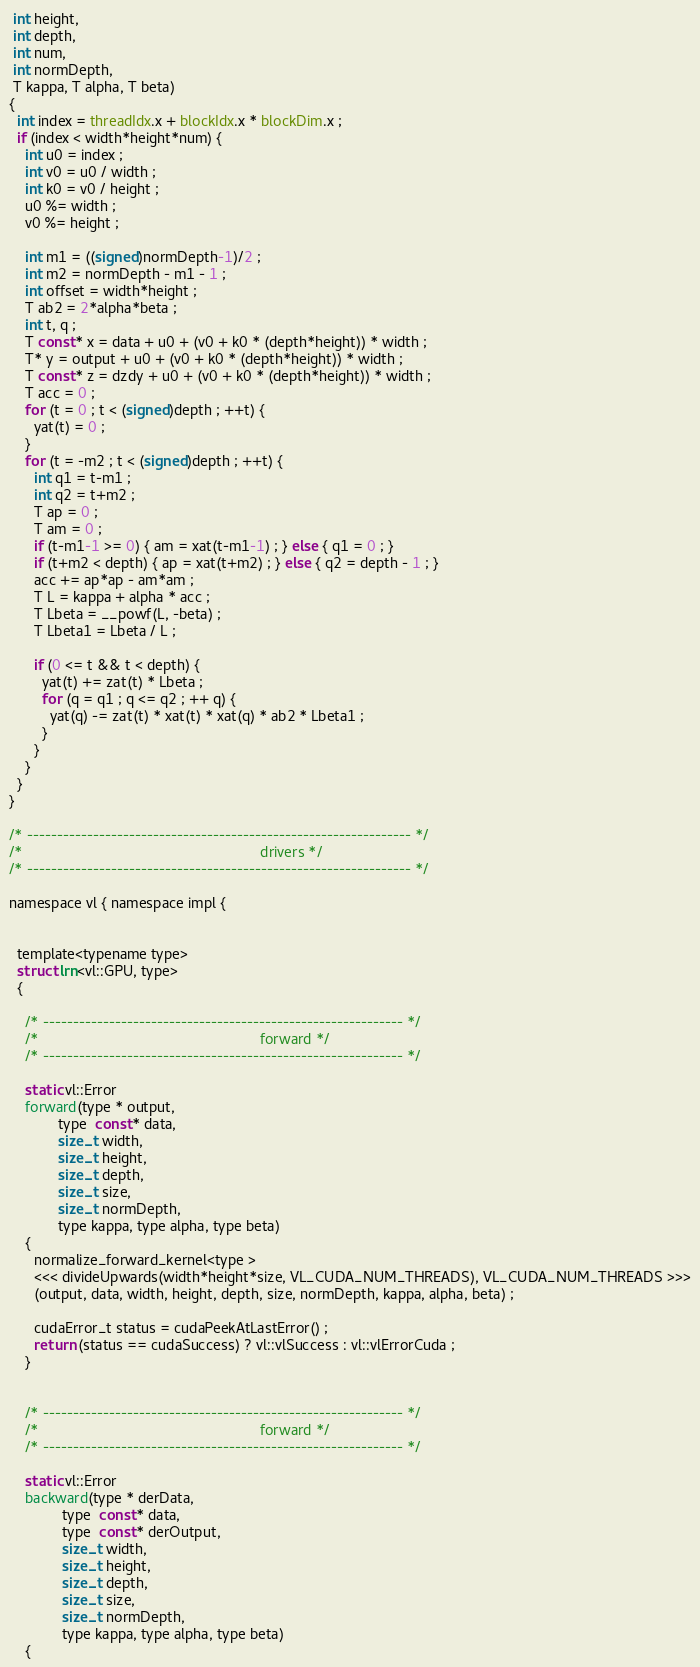Convert code to text. <code><loc_0><loc_0><loc_500><loc_500><_Cuda_> int height,
 int depth,
 int num,
 int normDepth,
 T kappa, T alpha, T beta)
{
  int index = threadIdx.x + blockIdx.x * blockDim.x ;
  if (index < width*height*num) {
    int u0 = index ;
    int v0 = u0 / width ;
    int k0 = v0 / height ;
    u0 %= width ;
    v0 %= height ;

    int m1 = ((signed)normDepth-1)/2 ;
    int m2 = normDepth - m1 - 1 ;
    int offset = width*height ;
    T ab2 = 2*alpha*beta ;
    int t, q ;
    T const* x = data + u0 + (v0 + k0 * (depth*height)) * width ;
    T* y = output + u0 + (v0 + k0 * (depth*height)) * width ;
    T const* z = dzdy + u0 + (v0 + k0 * (depth*height)) * width ;
    T acc = 0 ;
    for (t = 0 ; t < (signed)depth ; ++t) {
      yat(t) = 0 ;
    }
    for (t = -m2 ; t < (signed)depth ; ++t) {
      int q1 = t-m1 ;
      int q2 = t+m2 ;
      T ap = 0 ;
      T am = 0 ;
      if (t-m1-1 >= 0) { am = xat(t-m1-1) ; } else { q1 = 0 ; }
      if (t+m2 < depth) { ap = xat(t+m2) ; } else { q2 = depth - 1 ; }
      acc += ap*ap - am*am ;
      T L = kappa + alpha * acc ;
      T Lbeta = __powf(L, -beta) ;
      T Lbeta1 = Lbeta / L ;

      if (0 <= t && t < depth) {
        yat(t) += zat(t) * Lbeta ;
        for (q = q1 ; q <= q2 ; ++ q) {
          yat(q) -= zat(t) * xat(t) * xat(q) * ab2 * Lbeta1 ;
        }
      }
    }
  }
}

/* ---------------------------------------------------------------- */
/*                                                          drivers */
/* ---------------------------------------------------------------- */

namespace vl { namespace impl {


  template<typename type>
  struct lrn<vl::GPU, type>
  {

    /* ------------------------------------------------------------ */
    /*                                                      forward */
    /* ------------------------------------------------------------ */

    static vl::Error
    forward(type * output,
            type  const* data,
            size_t width,
            size_t height,
            size_t depth,
            size_t size,
            size_t normDepth,
            type kappa, type alpha, type beta)
    {
      normalize_forward_kernel<type >
      <<< divideUpwards(width*height*size, VL_CUDA_NUM_THREADS), VL_CUDA_NUM_THREADS >>>
      (output, data, width, height, depth, size, normDepth, kappa, alpha, beta) ;

      cudaError_t status = cudaPeekAtLastError() ;
      return (status == cudaSuccess) ? vl::vlSuccess : vl::vlErrorCuda ;
    }


    /* ------------------------------------------------------------ */
    /*                                                      forward */
    /* ------------------------------------------------------------ */

    static vl::Error
    backward(type * derData,
             type  const* data,
             type  const* derOutput,
             size_t width,
             size_t height,
             size_t depth,
             size_t size,
             size_t normDepth,
             type kappa, type alpha, type beta)
    {</code> 